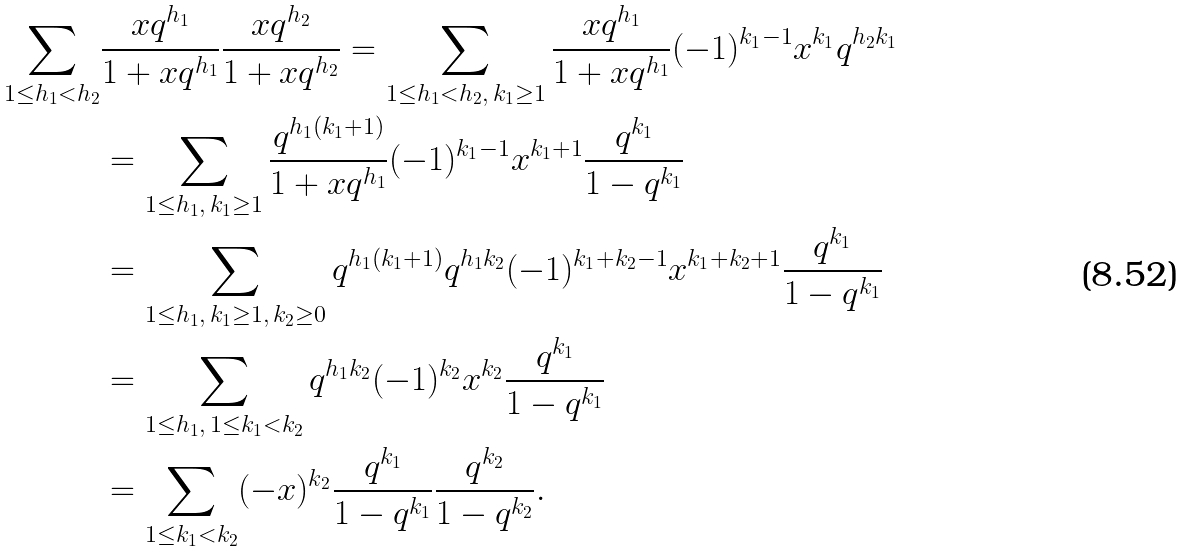Convert formula to latex. <formula><loc_0><loc_0><loc_500><loc_500>\sum _ { 1 \leq h _ { 1 } < h _ { 2 } } & \frac { x q ^ { h _ { 1 } } } { 1 + x q ^ { h _ { 1 } } } \frac { x q ^ { h _ { 2 } } } { 1 + x q ^ { h _ { 2 } } } = \sum _ { 1 \leq h _ { 1 } < h _ { 2 } , \, k _ { 1 } \geq 1 } \frac { x q ^ { h _ { 1 } } } { 1 + x q ^ { h _ { 1 } } } ( - 1 ) ^ { k _ { 1 } - 1 } x ^ { k _ { 1 } } q ^ { h _ { 2 } k _ { 1 } } \\ & = \sum _ { 1 \leq h _ { 1 } , \, k _ { 1 } \geq 1 } \frac { q ^ { h _ { 1 } ( k _ { 1 } + 1 ) } } { 1 + x q ^ { h _ { 1 } } } ( - 1 ) ^ { k _ { 1 } - 1 } x ^ { k _ { 1 } + 1 } \frac { q ^ { k _ { 1 } } } { 1 - q ^ { k _ { 1 } } } \\ & = \sum _ { 1 \leq h _ { 1 } , \, k _ { 1 } \geq 1 , \, k _ { 2 } \geq 0 } { q ^ { h _ { 1 } ( k _ { 1 } + 1 ) } } q ^ { h _ { 1 } k _ { 2 } } ( - 1 ) ^ { k _ { 1 } + k _ { 2 } - 1 } x ^ { k _ { 1 } + k _ { 2 } + 1 } \frac { q ^ { k _ { 1 } } } { 1 - q ^ { k _ { 1 } } } \\ & = \sum _ { 1 \leq h _ { 1 } , \, 1 \leq k _ { 1 } < k _ { 2 } } q ^ { h _ { 1 } k _ { 2 } } ( - 1 ) ^ { k _ { 2 } } x ^ { k _ { 2 } } \frac { q ^ { k _ { 1 } } } { 1 - q ^ { k _ { 1 } } } \\ & = \sum _ { 1 \leq k _ { 1 } < k _ { 2 } } ( - x ) ^ { k _ { 2 } } \frac { q ^ { k _ { 1 } } } { 1 - q ^ { k _ { 1 } } } \frac { q ^ { k _ { 2 } } } { 1 - q ^ { k _ { 2 } } } .</formula> 